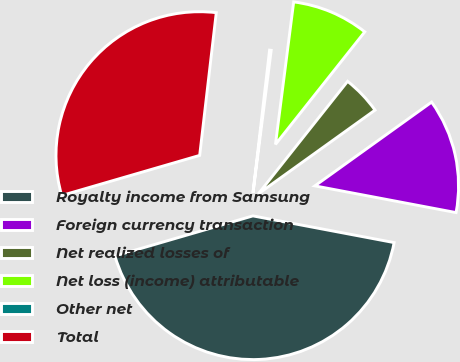Convert chart. <chart><loc_0><loc_0><loc_500><loc_500><pie_chart><fcel>Royalty income from Samsung<fcel>Foreign currency transaction<fcel>Net realized losses of<fcel>Net loss (income) attributable<fcel>Other net<fcel>Total<nl><fcel>42.52%<fcel>12.88%<fcel>4.42%<fcel>8.65%<fcel>0.18%<fcel>31.34%<nl></chart> 